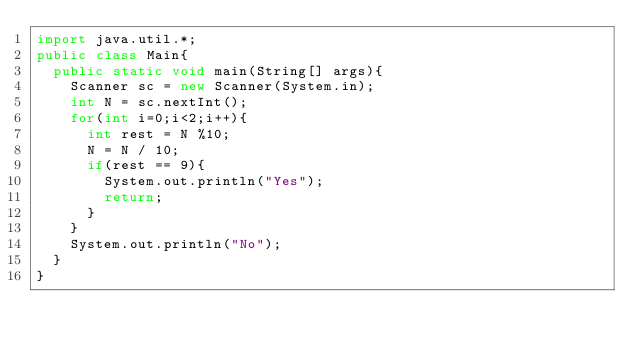<code> <loc_0><loc_0><loc_500><loc_500><_Java_>import java.util.*;
public class Main{
  public static void main(String[] args){
    Scanner sc = new Scanner(System.in);
    int N = sc.nextInt();
    for(int i=0;i<2;i++){
      int rest = N %10;
      N = N / 10;
      if(rest == 9){
        System.out.println("Yes");
        return;
      }
    }
    System.out.println("No");
  }
}
</code> 